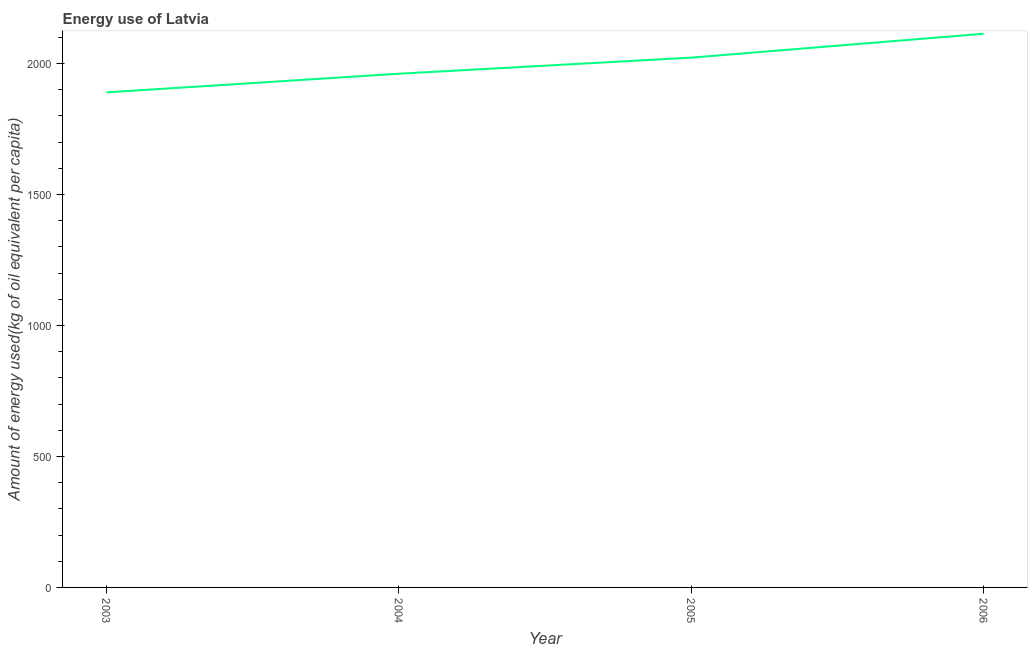What is the amount of energy used in 2003?
Offer a very short reply. 1889.95. Across all years, what is the maximum amount of energy used?
Ensure brevity in your answer.  2113.71. Across all years, what is the minimum amount of energy used?
Your answer should be compact. 1889.95. What is the sum of the amount of energy used?
Offer a very short reply. 7987.33. What is the difference between the amount of energy used in 2003 and 2005?
Offer a terse response. -132.61. What is the average amount of energy used per year?
Offer a very short reply. 1996.83. What is the median amount of energy used?
Ensure brevity in your answer.  1991.83. Do a majority of the years between 2006 and 2005 (inclusive) have amount of energy used greater than 100 kg?
Provide a succinct answer. No. What is the ratio of the amount of energy used in 2003 to that in 2005?
Your response must be concise. 0.93. Is the amount of energy used in 2003 less than that in 2005?
Make the answer very short. Yes. What is the difference between the highest and the second highest amount of energy used?
Make the answer very short. 91.15. What is the difference between the highest and the lowest amount of energy used?
Ensure brevity in your answer.  223.76. In how many years, is the amount of energy used greater than the average amount of energy used taken over all years?
Ensure brevity in your answer.  2. Does the amount of energy used monotonically increase over the years?
Offer a very short reply. Yes. How many years are there in the graph?
Ensure brevity in your answer.  4. What is the difference between two consecutive major ticks on the Y-axis?
Offer a terse response. 500. Are the values on the major ticks of Y-axis written in scientific E-notation?
Provide a succinct answer. No. Does the graph contain any zero values?
Provide a succinct answer. No. What is the title of the graph?
Keep it short and to the point. Energy use of Latvia. What is the label or title of the Y-axis?
Give a very brief answer. Amount of energy used(kg of oil equivalent per capita). What is the Amount of energy used(kg of oil equivalent per capita) of 2003?
Provide a succinct answer. 1889.95. What is the Amount of energy used(kg of oil equivalent per capita) of 2004?
Provide a succinct answer. 1961.1. What is the Amount of energy used(kg of oil equivalent per capita) of 2005?
Keep it short and to the point. 2022.56. What is the Amount of energy used(kg of oil equivalent per capita) in 2006?
Offer a very short reply. 2113.71. What is the difference between the Amount of energy used(kg of oil equivalent per capita) in 2003 and 2004?
Offer a very short reply. -71.15. What is the difference between the Amount of energy used(kg of oil equivalent per capita) in 2003 and 2005?
Provide a short and direct response. -132.61. What is the difference between the Amount of energy used(kg of oil equivalent per capita) in 2003 and 2006?
Your response must be concise. -223.76. What is the difference between the Amount of energy used(kg of oil equivalent per capita) in 2004 and 2005?
Give a very brief answer. -61.46. What is the difference between the Amount of energy used(kg of oil equivalent per capita) in 2004 and 2006?
Make the answer very short. -152.61. What is the difference between the Amount of energy used(kg of oil equivalent per capita) in 2005 and 2006?
Your response must be concise. -91.15. What is the ratio of the Amount of energy used(kg of oil equivalent per capita) in 2003 to that in 2004?
Your response must be concise. 0.96. What is the ratio of the Amount of energy used(kg of oil equivalent per capita) in 2003 to that in 2005?
Your response must be concise. 0.93. What is the ratio of the Amount of energy used(kg of oil equivalent per capita) in 2003 to that in 2006?
Offer a terse response. 0.89. What is the ratio of the Amount of energy used(kg of oil equivalent per capita) in 2004 to that in 2005?
Keep it short and to the point. 0.97. What is the ratio of the Amount of energy used(kg of oil equivalent per capita) in 2004 to that in 2006?
Your answer should be compact. 0.93. 